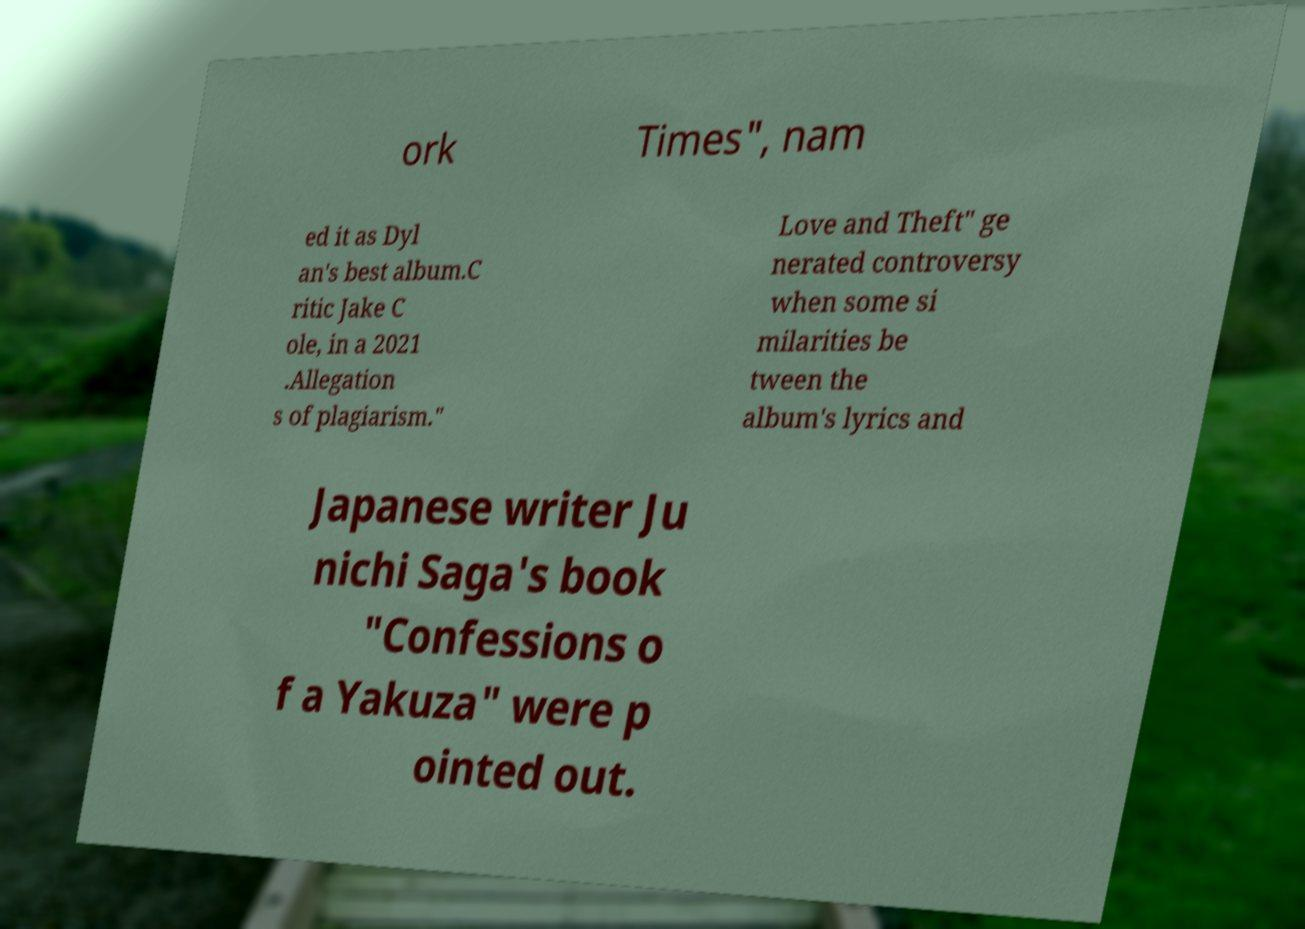Please read and relay the text visible in this image. What does it say? ork Times", nam ed it as Dyl an's best album.C ritic Jake C ole, in a 2021 .Allegation s of plagiarism." Love and Theft" ge nerated controversy when some si milarities be tween the album's lyrics and Japanese writer Ju nichi Saga's book "Confessions o f a Yakuza" were p ointed out. 